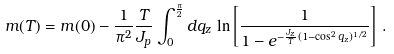Convert formula to latex. <formula><loc_0><loc_0><loc_500><loc_500>m ( T ) = m ( 0 ) - \frac { 1 } { \pi ^ { 2 } } \frac { T } { J _ { p } } \int _ { 0 } ^ { \frac { \pi } { 2 } } d q _ { z } \, \ln \left [ \frac { 1 } { 1 - e ^ { - \frac { J _ { z } } { T } ( 1 - \cos ^ { 2 } q _ { z } ) ^ { 1 / 2 } } } \right ] \, .</formula> 